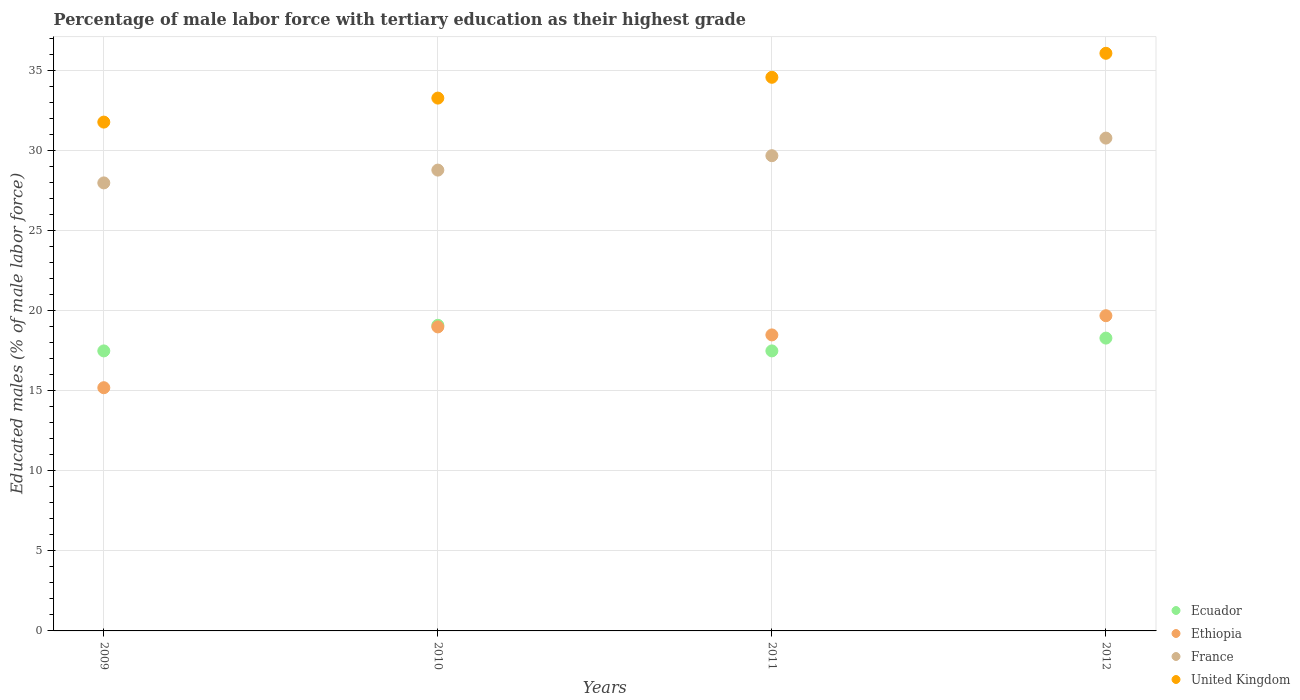How many different coloured dotlines are there?
Make the answer very short. 4. What is the percentage of male labor force with tertiary education in Ethiopia in 2012?
Your answer should be compact. 19.7. Across all years, what is the maximum percentage of male labor force with tertiary education in Ecuador?
Your response must be concise. 19.1. Across all years, what is the minimum percentage of male labor force with tertiary education in Ecuador?
Provide a succinct answer. 17.5. In which year was the percentage of male labor force with tertiary education in Ecuador minimum?
Give a very brief answer. 2009. What is the total percentage of male labor force with tertiary education in United Kingdom in the graph?
Ensure brevity in your answer.  135.8. What is the difference between the percentage of male labor force with tertiary education in Ecuador in 2009 and that in 2010?
Make the answer very short. -1.6. What is the average percentage of male labor force with tertiary education in Ethiopia per year?
Provide a succinct answer. 18.1. In how many years, is the percentage of male labor force with tertiary education in France greater than 24 %?
Offer a very short reply. 4. What is the ratio of the percentage of male labor force with tertiary education in United Kingdom in 2009 to that in 2011?
Ensure brevity in your answer.  0.92. Is the percentage of male labor force with tertiary education in Ecuador in 2009 less than that in 2011?
Keep it short and to the point. No. Is the difference between the percentage of male labor force with tertiary education in Ecuador in 2009 and 2011 greater than the difference between the percentage of male labor force with tertiary education in Ethiopia in 2009 and 2011?
Your response must be concise. Yes. What is the difference between the highest and the second highest percentage of male labor force with tertiary education in Ecuador?
Your answer should be very brief. 0.8. What is the difference between the highest and the lowest percentage of male labor force with tertiary education in France?
Make the answer very short. 2.8. Is the sum of the percentage of male labor force with tertiary education in Ethiopia in 2011 and 2012 greater than the maximum percentage of male labor force with tertiary education in France across all years?
Make the answer very short. Yes. Is it the case that in every year, the sum of the percentage of male labor force with tertiary education in Ecuador and percentage of male labor force with tertiary education in France  is greater than the sum of percentage of male labor force with tertiary education in United Kingdom and percentage of male labor force with tertiary education in Ethiopia?
Offer a very short reply. Yes. Does the percentage of male labor force with tertiary education in France monotonically increase over the years?
Keep it short and to the point. Yes. Is the percentage of male labor force with tertiary education in France strictly greater than the percentage of male labor force with tertiary education in Ecuador over the years?
Keep it short and to the point. Yes. How many dotlines are there?
Make the answer very short. 4. How many years are there in the graph?
Offer a terse response. 4. What is the difference between two consecutive major ticks on the Y-axis?
Your answer should be very brief. 5. Are the values on the major ticks of Y-axis written in scientific E-notation?
Provide a short and direct response. No. Does the graph contain any zero values?
Ensure brevity in your answer.  No. What is the title of the graph?
Your answer should be very brief. Percentage of male labor force with tertiary education as their highest grade. Does "American Samoa" appear as one of the legend labels in the graph?
Offer a very short reply. No. What is the label or title of the X-axis?
Offer a terse response. Years. What is the label or title of the Y-axis?
Provide a short and direct response. Educated males (% of male labor force). What is the Educated males (% of male labor force) of Ethiopia in 2009?
Your response must be concise. 15.2. What is the Educated males (% of male labor force) in United Kingdom in 2009?
Provide a succinct answer. 31.8. What is the Educated males (% of male labor force) in Ecuador in 2010?
Your answer should be very brief. 19.1. What is the Educated males (% of male labor force) of France in 2010?
Ensure brevity in your answer.  28.8. What is the Educated males (% of male labor force) in United Kingdom in 2010?
Your answer should be compact. 33.3. What is the Educated males (% of male labor force) in France in 2011?
Provide a succinct answer. 29.7. What is the Educated males (% of male labor force) of United Kingdom in 2011?
Give a very brief answer. 34.6. What is the Educated males (% of male labor force) of Ecuador in 2012?
Your response must be concise. 18.3. What is the Educated males (% of male labor force) of Ethiopia in 2012?
Offer a very short reply. 19.7. What is the Educated males (% of male labor force) of France in 2012?
Provide a short and direct response. 30.8. What is the Educated males (% of male labor force) in United Kingdom in 2012?
Provide a short and direct response. 36.1. Across all years, what is the maximum Educated males (% of male labor force) in Ecuador?
Keep it short and to the point. 19.1. Across all years, what is the maximum Educated males (% of male labor force) of Ethiopia?
Keep it short and to the point. 19.7. Across all years, what is the maximum Educated males (% of male labor force) of France?
Offer a very short reply. 30.8. Across all years, what is the maximum Educated males (% of male labor force) of United Kingdom?
Provide a short and direct response. 36.1. Across all years, what is the minimum Educated males (% of male labor force) of Ethiopia?
Offer a terse response. 15.2. Across all years, what is the minimum Educated males (% of male labor force) in France?
Your answer should be very brief. 28. Across all years, what is the minimum Educated males (% of male labor force) of United Kingdom?
Your answer should be very brief. 31.8. What is the total Educated males (% of male labor force) in Ecuador in the graph?
Your answer should be very brief. 72.4. What is the total Educated males (% of male labor force) of Ethiopia in the graph?
Offer a very short reply. 72.4. What is the total Educated males (% of male labor force) of France in the graph?
Make the answer very short. 117.3. What is the total Educated males (% of male labor force) in United Kingdom in the graph?
Your answer should be very brief. 135.8. What is the difference between the Educated males (% of male labor force) in United Kingdom in 2009 and that in 2010?
Provide a short and direct response. -1.5. What is the difference between the Educated males (% of male labor force) in Ethiopia in 2009 and that in 2011?
Ensure brevity in your answer.  -3.3. What is the difference between the Educated males (% of male labor force) in United Kingdom in 2009 and that in 2012?
Give a very brief answer. -4.3. What is the difference between the Educated males (% of male labor force) in Ecuador in 2010 and that in 2011?
Make the answer very short. 1.6. What is the difference between the Educated males (% of male labor force) of Ethiopia in 2010 and that in 2011?
Your response must be concise. 0.5. What is the difference between the Educated males (% of male labor force) in United Kingdom in 2010 and that in 2011?
Keep it short and to the point. -1.3. What is the difference between the Educated males (% of male labor force) in Ecuador in 2011 and that in 2012?
Provide a short and direct response. -0.8. What is the difference between the Educated males (% of male labor force) in France in 2011 and that in 2012?
Your answer should be very brief. -1.1. What is the difference between the Educated males (% of male labor force) of Ecuador in 2009 and the Educated males (% of male labor force) of Ethiopia in 2010?
Make the answer very short. -1.5. What is the difference between the Educated males (% of male labor force) in Ecuador in 2009 and the Educated males (% of male labor force) in France in 2010?
Offer a terse response. -11.3. What is the difference between the Educated males (% of male labor force) of Ecuador in 2009 and the Educated males (% of male labor force) of United Kingdom in 2010?
Give a very brief answer. -15.8. What is the difference between the Educated males (% of male labor force) in Ethiopia in 2009 and the Educated males (% of male labor force) in France in 2010?
Your answer should be compact. -13.6. What is the difference between the Educated males (% of male labor force) of Ethiopia in 2009 and the Educated males (% of male labor force) of United Kingdom in 2010?
Keep it short and to the point. -18.1. What is the difference between the Educated males (% of male labor force) in Ecuador in 2009 and the Educated males (% of male labor force) in France in 2011?
Your answer should be very brief. -12.2. What is the difference between the Educated males (% of male labor force) in Ecuador in 2009 and the Educated males (% of male labor force) in United Kingdom in 2011?
Provide a succinct answer. -17.1. What is the difference between the Educated males (% of male labor force) in Ethiopia in 2009 and the Educated males (% of male labor force) in France in 2011?
Ensure brevity in your answer.  -14.5. What is the difference between the Educated males (% of male labor force) of Ethiopia in 2009 and the Educated males (% of male labor force) of United Kingdom in 2011?
Your response must be concise. -19.4. What is the difference between the Educated males (% of male labor force) of France in 2009 and the Educated males (% of male labor force) of United Kingdom in 2011?
Keep it short and to the point. -6.6. What is the difference between the Educated males (% of male labor force) in Ecuador in 2009 and the Educated males (% of male labor force) in United Kingdom in 2012?
Keep it short and to the point. -18.6. What is the difference between the Educated males (% of male labor force) in Ethiopia in 2009 and the Educated males (% of male labor force) in France in 2012?
Your response must be concise. -15.6. What is the difference between the Educated males (% of male labor force) in Ethiopia in 2009 and the Educated males (% of male labor force) in United Kingdom in 2012?
Give a very brief answer. -20.9. What is the difference between the Educated males (% of male labor force) in Ecuador in 2010 and the Educated males (% of male labor force) in France in 2011?
Your response must be concise. -10.6. What is the difference between the Educated males (% of male labor force) of Ecuador in 2010 and the Educated males (% of male labor force) of United Kingdom in 2011?
Ensure brevity in your answer.  -15.5. What is the difference between the Educated males (% of male labor force) in Ethiopia in 2010 and the Educated males (% of male labor force) in United Kingdom in 2011?
Make the answer very short. -15.6. What is the difference between the Educated males (% of male labor force) of Ecuador in 2010 and the Educated males (% of male labor force) of Ethiopia in 2012?
Offer a terse response. -0.6. What is the difference between the Educated males (% of male labor force) of Ecuador in 2010 and the Educated males (% of male labor force) of France in 2012?
Your answer should be compact. -11.7. What is the difference between the Educated males (% of male labor force) in Ethiopia in 2010 and the Educated males (% of male labor force) in United Kingdom in 2012?
Offer a very short reply. -17.1. What is the difference between the Educated males (% of male labor force) in France in 2010 and the Educated males (% of male labor force) in United Kingdom in 2012?
Give a very brief answer. -7.3. What is the difference between the Educated males (% of male labor force) in Ecuador in 2011 and the Educated males (% of male labor force) in Ethiopia in 2012?
Give a very brief answer. -2.2. What is the difference between the Educated males (% of male labor force) in Ecuador in 2011 and the Educated males (% of male labor force) in United Kingdom in 2012?
Make the answer very short. -18.6. What is the difference between the Educated males (% of male labor force) of Ethiopia in 2011 and the Educated males (% of male labor force) of France in 2012?
Provide a short and direct response. -12.3. What is the difference between the Educated males (% of male labor force) in Ethiopia in 2011 and the Educated males (% of male labor force) in United Kingdom in 2012?
Your response must be concise. -17.6. What is the average Educated males (% of male labor force) of Ecuador per year?
Your answer should be compact. 18.1. What is the average Educated males (% of male labor force) in France per year?
Provide a succinct answer. 29.32. What is the average Educated males (% of male labor force) in United Kingdom per year?
Make the answer very short. 33.95. In the year 2009, what is the difference between the Educated males (% of male labor force) of Ecuador and Educated males (% of male labor force) of Ethiopia?
Your answer should be very brief. 2.3. In the year 2009, what is the difference between the Educated males (% of male labor force) of Ecuador and Educated males (% of male labor force) of United Kingdom?
Offer a very short reply. -14.3. In the year 2009, what is the difference between the Educated males (% of male labor force) in Ethiopia and Educated males (% of male labor force) in United Kingdom?
Keep it short and to the point. -16.6. In the year 2010, what is the difference between the Educated males (% of male labor force) in Ecuador and Educated males (% of male labor force) in France?
Offer a terse response. -9.7. In the year 2010, what is the difference between the Educated males (% of male labor force) of Ecuador and Educated males (% of male labor force) of United Kingdom?
Provide a short and direct response. -14.2. In the year 2010, what is the difference between the Educated males (% of male labor force) in Ethiopia and Educated males (% of male labor force) in United Kingdom?
Offer a terse response. -14.3. In the year 2011, what is the difference between the Educated males (% of male labor force) in Ecuador and Educated males (% of male labor force) in France?
Your answer should be compact. -12.2. In the year 2011, what is the difference between the Educated males (% of male labor force) in Ecuador and Educated males (% of male labor force) in United Kingdom?
Make the answer very short. -17.1. In the year 2011, what is the difference between the Educated males (% of male labor force) in Ethiopia and Educated males (% of male labor force) in France?
Provide a succinct answer. -11.2. In the year 2011, what is the difference between the Educated males (% of male labor force) of Ethiopia and Educated males (% of male labor force) of United Kingdom?
Provide a succinct answer. -16.1. In the year 2012, what is the difference between the Educated males (% of male labor force) of Ecuador and Educated males (% of male labor force) of United Kingdom?
Your response must be concise. -17.8. In the year 2012, what is the difference between the Educated males (% of male labor force) in Ethiopia and Educated males (% of male labor force) in France?
Your answer should be compact. -11.1. In the year 2012, what is the difference between the Educated males (% of male labor force) in Ethiopia and Educated males (% of male labor force) in United Kingdom?
Provide a succinct answer. -16.4. In the year 2012, what is the difference between the Educated males (% of male labor force) in France and Educated males (% of male labor force) in United Kingdom?
Give a very brief answer. -5.3. What is the ratio of the Educated males (% of male labor force) in Ecuador in 2009 to that in 2010?
Your answer should be very brief. 0.92. What is the ratio of the Educated males (% of male labor force) in Ethiopia in 2009 to that in 2010?
Keep it short and to the point. 0.8. What is the ratio of the Educated males (% of male labor force) of France in 2009 to that in 2010?
Keep it short and to the point. 0.97. What is the ratio of the Educated males (% of male labor force) in United Kingdom in 2009 to that in 2010?
Provide a short and direct response. 0.95. What is the ratio of the Educated males (% of male labor force) of Ethiopia in 2009 to that in 2011?
Give a very brief answer. 0.82. What is the ratio of the Educated males (% of male labor force) in France in 2009 to that in 2011?
Your answer should be compact. 0.94. What is the ratio of the Educated males (% of male labor force) in United Kingdom in 2009 to that in 2011?
Offer a terse response. 0.92. What is the ratio of the Educated males (% of male labor force) in Ecuador in 2009 to that in 2012?
Keep it short and to the point. 0.96. What is the ratio of the Educated males (% of male labor force) in Ethiopia in 2009 to that in 2012?
Provide a short and direct response. 0.77. What is the ratio of the Educated males (% of male labor force) of United Kingdom in 2009 to that in 2012?
Ensure brevity in your answer.  0.88. What is the ratio of the Educated males (% of male labor force) in Ecuador in 2010 to that in 2011?
Your answer should be very brief. 1.09. What is the ratio of the Educated males (% of male labor force) of France in 2010 to that in 2011?
Offer a terse response. 0.97. What is the ratio of the Educated males (% of male labor force) of United Kingdom in 2010 to that in 2011?
Keep it short and to the point. 0.96. What is the ratio of the Educated males (% of male labor force) of Ecuador in 2010 to that in 2012?
Give a very brief answer. 1.04. What is the ratio of the Educated males (% of male labor force) of Ethiopia in 2010 to that in 2012?
Give a very brief answer. 0.96. What is the ratio of the Educated males (% of male labor force) of France in 2010 to that in 2012?
Your response must be concise. 0.94. What is the ratio of the Educated males (% of male labor force) of United Kingdom in 2010 to that in 2012?
Give a very brief answer. 0.92. What is the ratio of the Educated males (% of male labor force) of Ecuador in 2011 to that in 2012?
Ensure brevity in your answer.  0.96. What is the ratio of the Educated males (% of male labor force) in Ethiopia in 2011 to that in 2012?
Offer a terse response. 0.94. What is the ratio of the Educated males (% of male labor force) in France in 2011 to that in 2012?
Your answer should be compact. 0.96. What is the ratio of the Educated males (% of male labor force) of United Kingdom in 2011 to that in 2012?
Give a very brief answer. 0.96. What is the difference between the highest and the second highest Educated males (% of male labor force) of France?
Your answer should be compact. 1.1. What is the difference between the highest and the lowest Educated males (% of male labor force) of Ethiopia?
Your response must be concise. 4.5. What is the difference between the highest and the lowest Educated males (% of male labor force) of France?
Give a very brief answer. 2.8. What is the difference between the highest and the lowest Educated males (% of male labor force) of United Kingdom?
Ensure brevity in your answer.  4.3. 